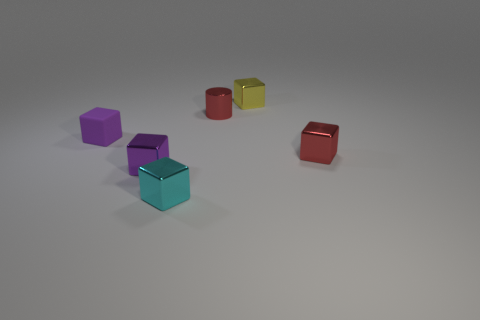There is a cube that is on the right side of the yellow metal cube; is its color the same as the metallic cylinder?
Keep it short and to the point. Yes. How many small metallic things are both in front of the small purple metal object and behind the purple matte block?
Ensure brevity in your answer.  0. How many other things are the same material as the yellow block?
Offer a terse response. 4. Does the small red object right of the yellow metal cube have the same material as the tiny cyan block?
Ensure brevity in your answer.  Yes. What number of other objects are there of the same color as the tiny rubber block?
Your answer should be very brief. 1. What is the shape of the yellow object that is the same size as the rubber block?
Offer a terse response. Cube. Do the small thing that is on the left side of the purple shiny cube and the shiny block that is to the left of the cyan metal thing have the same color?
Keep it short and to the point. Yes. There is a tiny purple block that is behind the small purple thing in front of the tiny metallic thing that is on the right side of the small yellow object; what is it made of?
Offer a very short reply. Rubber. Are there any other green cylinders that have the same size as the cylinder?
Your response must be concise. No. What material is the purple block that is the same size as the purple metallic thing?
Offer a terse response. Rubber. 